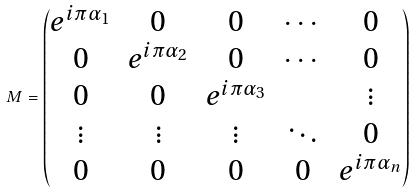Convert formula to latex. <formula><loc_0><loc_0><loc_500><loc_500>M = \begin{pmatrix} e ^ { i \pi \alpha _ { 1 } } & 0 & 0 & \cdots & 0 \\ 0 & e ^ { i \pi \alpha _ { 2 } } & 0 & \cdots & 0 \\ 0 & 0 & e ^ { i \pi \alpha _ { 3 } } & & \vdots \\ \vdots & \vdots & \vdots & \ddots & 0 \\ 0 & 0 & 0 & 0 & e ^ { i \pi \alpha _ { n } } \\ \end{pmatrix}</formula> 